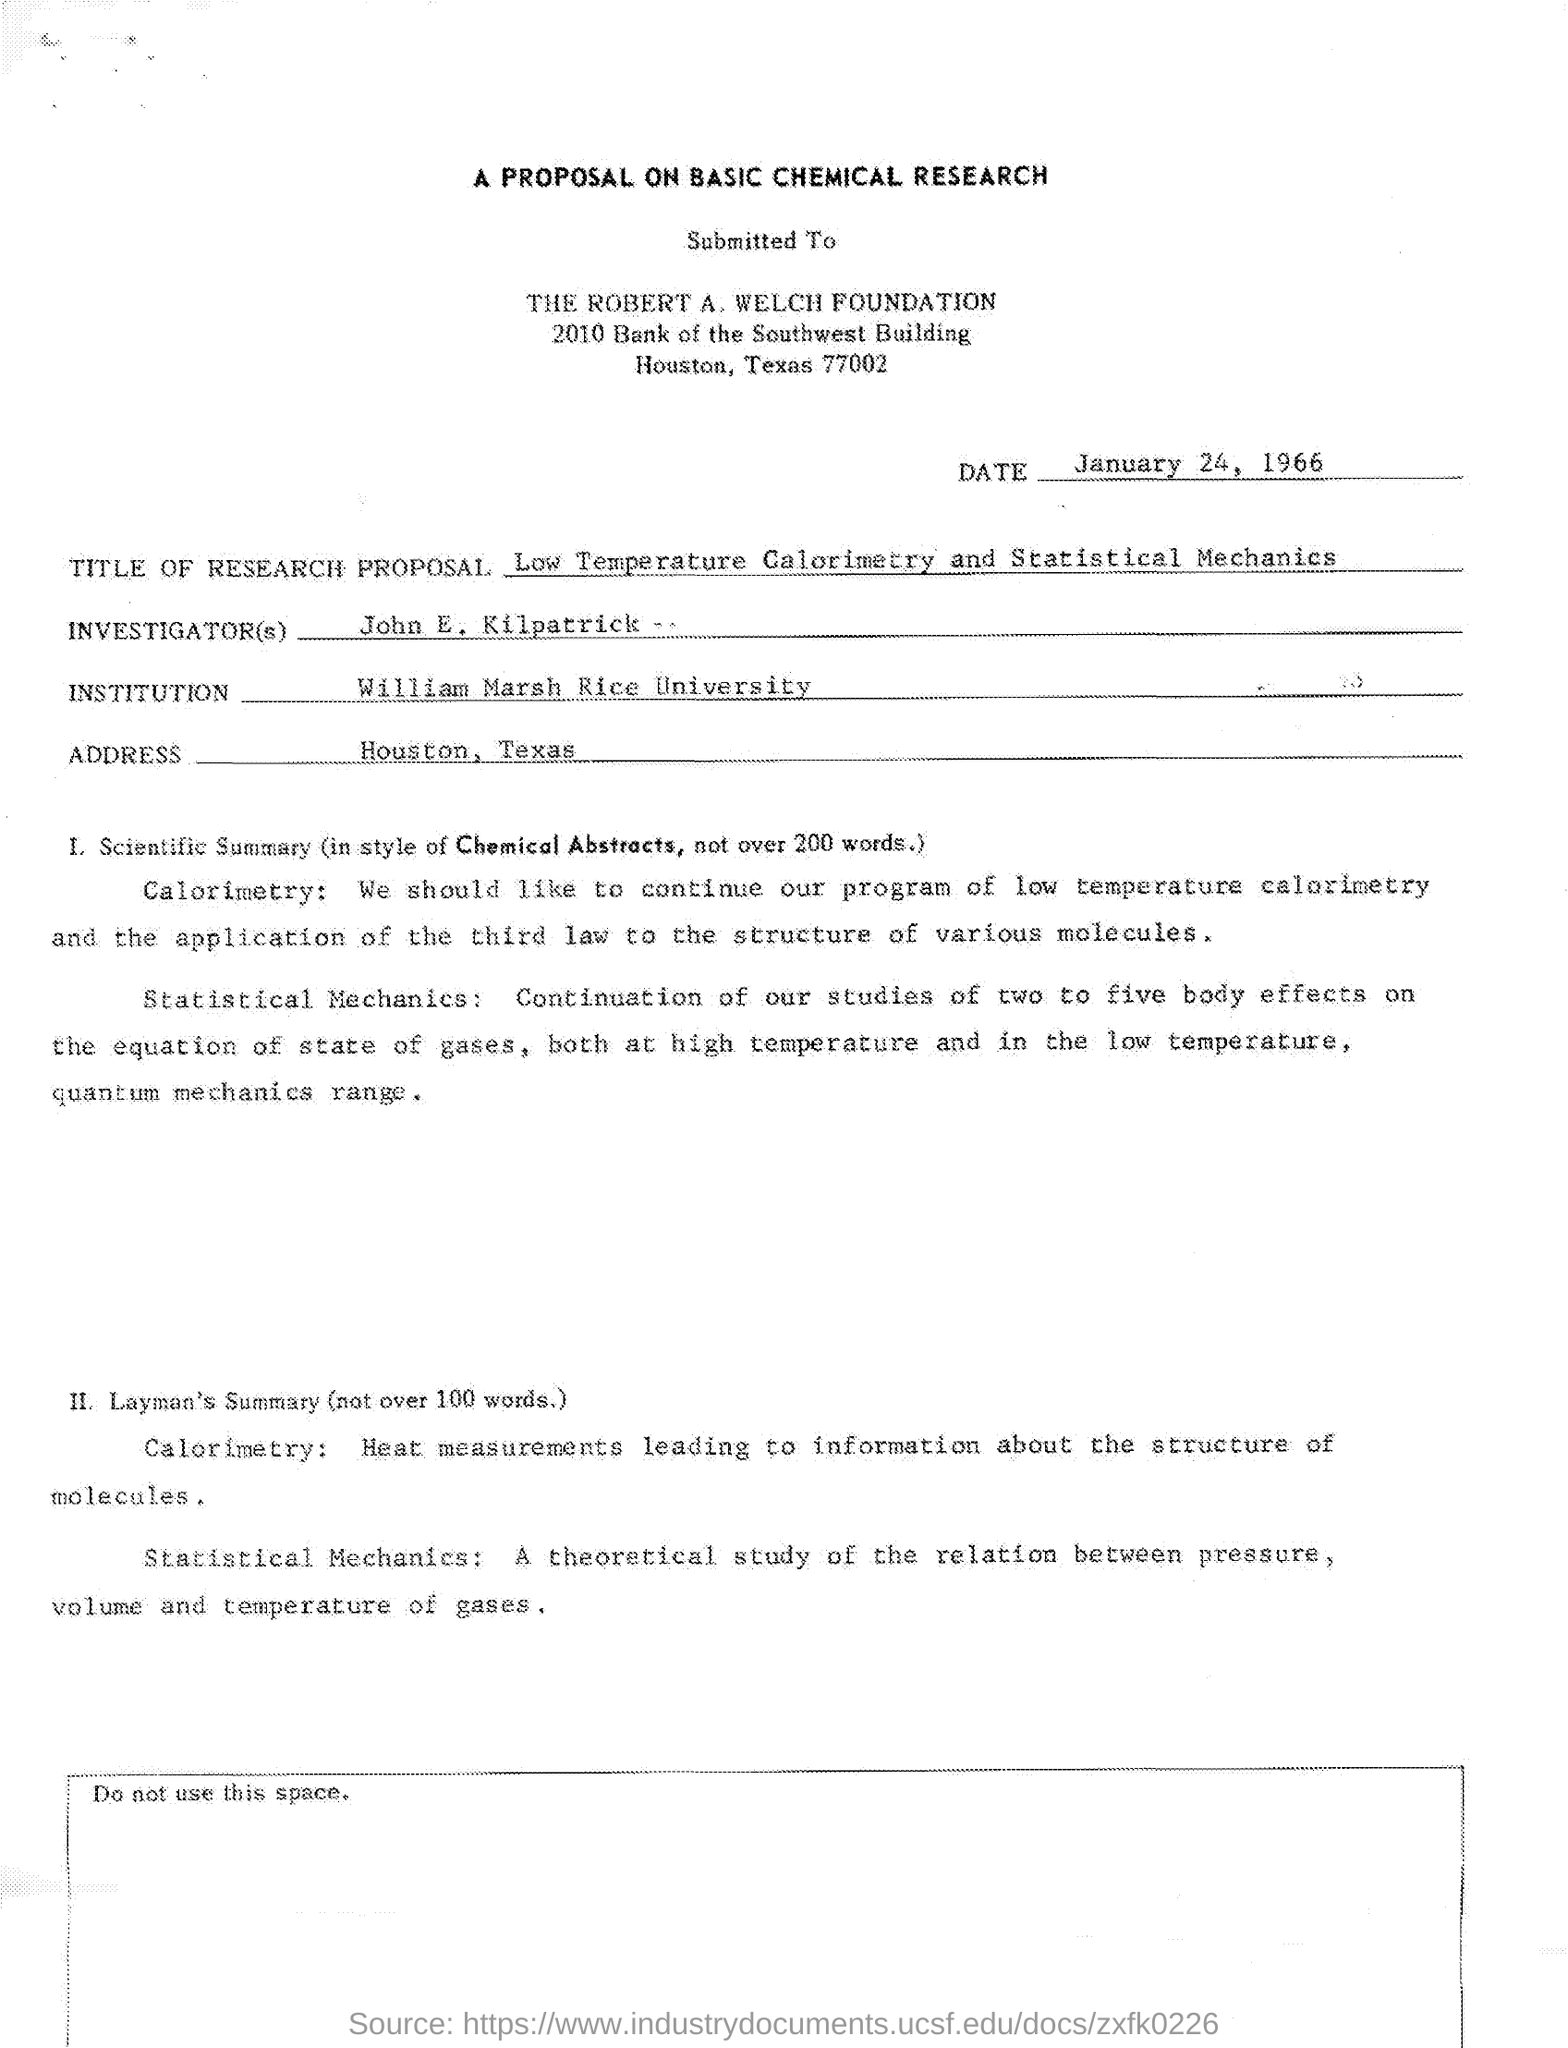Point out several critical features in this image. The title of the article is "Low Temperature Calorimetry and Statistical Mechanics. John E. Kilpatrick is the investigator. 